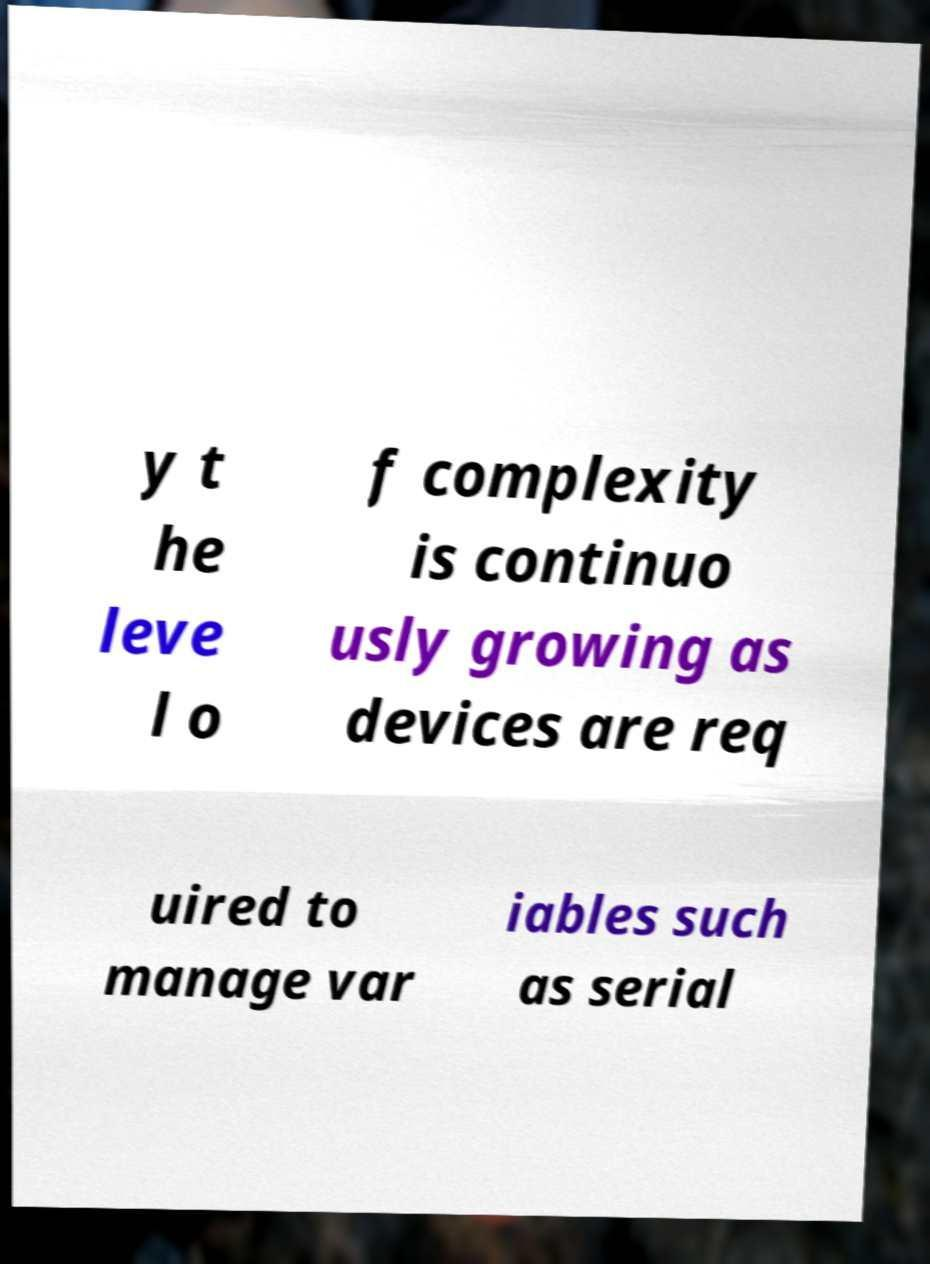Could you assist in decoding the text presented in this image and type it out clearly? y t he leve l o f complexity is continuo usly growing as devices are req uired to manage var iables such as serial 